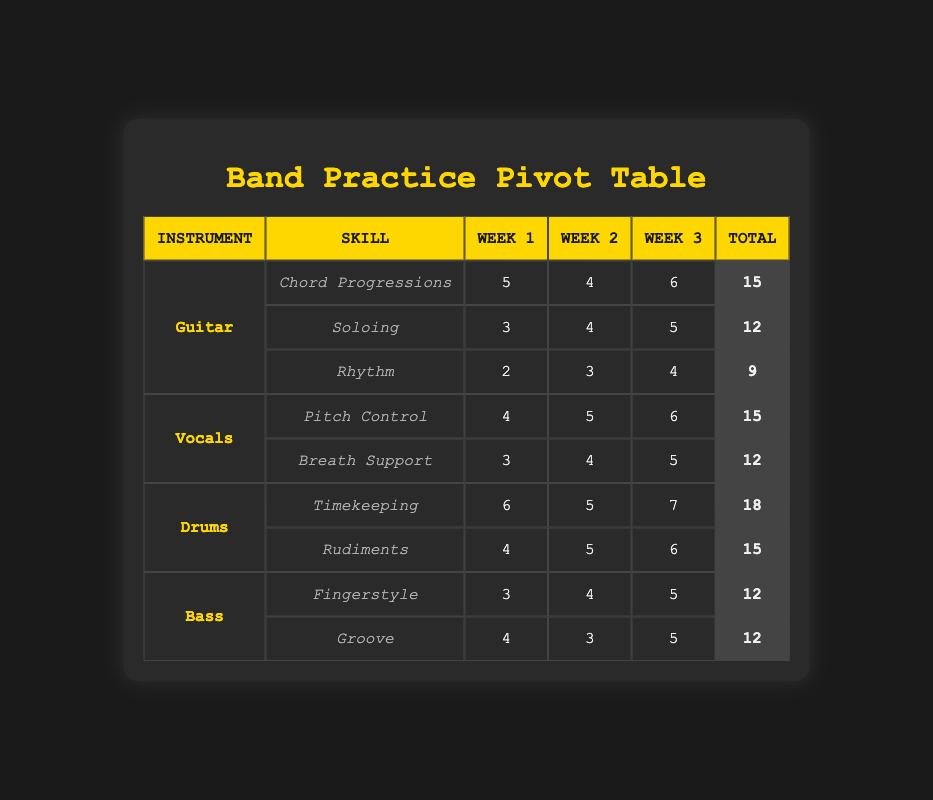What is the total practice time for Mike in Week 1? In the table, we look for Mike's entries under Week 1. For Mike, the practice hours for Timekeeping is 6 and for Rudiments is 4. Adding these hours together gives us 6 + 4 = 10.
Answer: 10 How many hours did Sarah practice Pitch Control across all weeks? To find the total practice hours: for Week 1, Sarah practiced 4 hours; for Week 2, she practiced 5 hours; and for Week 3, she practiced 6 hours. Summing these amounts gives 4 + 5 + 6 = 15.
Answer: 15 Which skill did Alex spend the most hours practicing in Week 3? In Week 3, Alex's practice hours for Chord Progressions are 6, for Soloing are 5, and for Rhythm are 4. The highest value is 6, which corresponds to Chord Progressions.
Answer: Chord Progressions Is it true that Emily practiced more hours on Fingerstyle than on Groove in Week 2? Emily practiced 4 hours on Fingerstyle and 3 hours on Groove during Week 2. Since 4 is greater than 3, it is true.
Answer: Yes What is the average practice time that Mike spent on Rudiments over the three weeks? Mike's practice hours on Rudiments are: 4 hours in Week 1, 5 hours in Week 2, and 6 hours in Week 3. To find the average, we calculate (4 + 5 + 6) = 15, then divide by the number of weeks (3) which gives 15/3 = 5.
Answer: 5 Which instrument has the highest total practice time across all weeks? To find the instrument with the highest total, we calculate the total hours for each: Guitar (15 + 12 + 9 = 36), Vocals (15 + 12 = 27), Drums (18 + 15 = 33), Bass (12 + 12 = 24). Guitar has the highest total of 36 hours.
Answer: Guitar What are the total practice hours for all skills combined in Week 2? In Week 2, we add up all the practice hours: Guitar (4 + 4 + 3 = 11), Vocals (5 + 4 = 9), Drums (5 + 5 = 10), Bass (4 + 3 = 7). Adding these totals together yields 11 + 9 + 10 + 7 = 37.
Answer: 37 Did any band member practice the same number of hours for both Groove and Fingerstyle? In the table, Emily practiced 12 hours total for both Groove and Fingerstyle (4 + 3 for Fingerstyle and 5 + 4 for Groove). Since both totals amount to 12, it is true.
Answer: Yes 